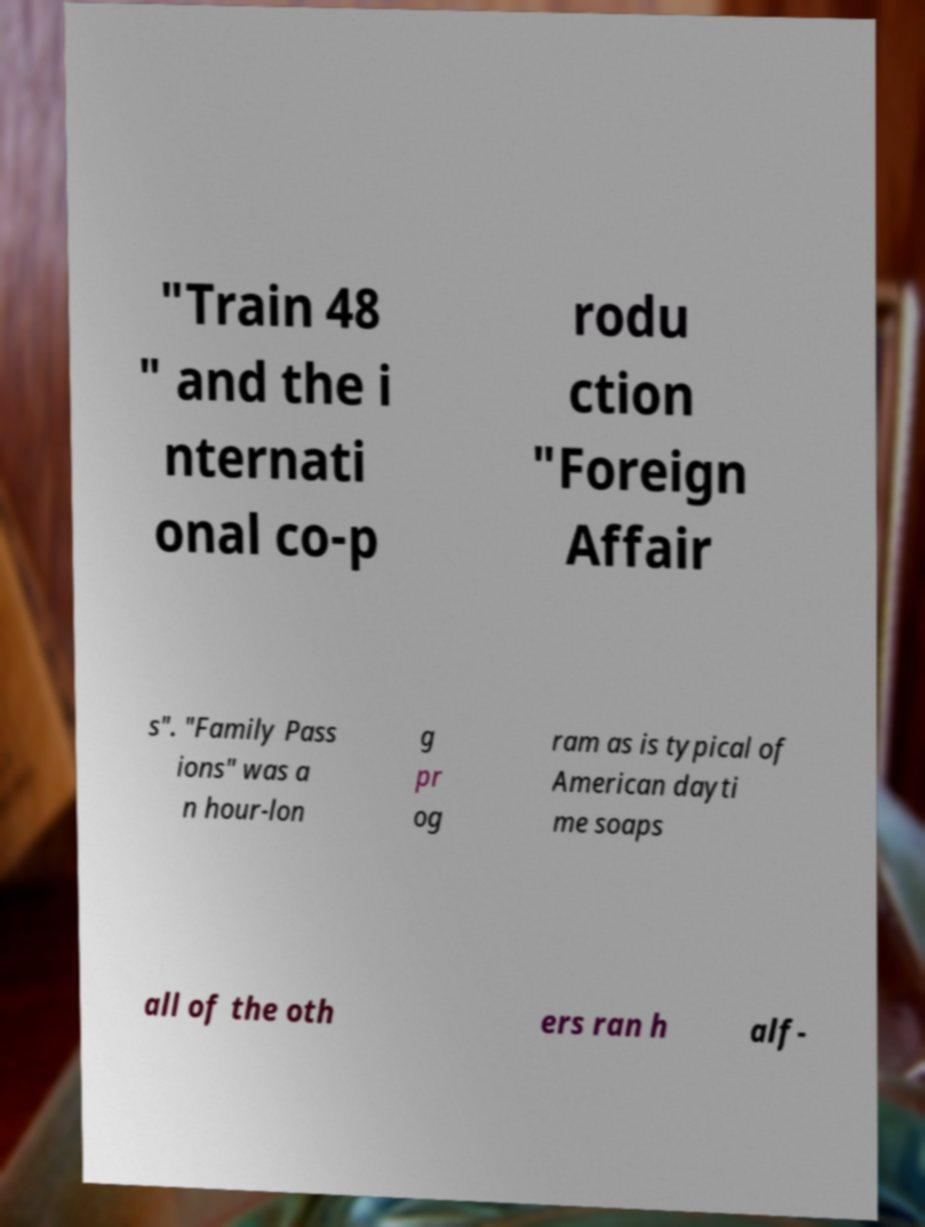Could you extract and type out the text from this image? "Train 48 " and the i nternati onal co-p rodu ction "Foreign Affair s". "Family Pass ions" was a n hour-lon g pr og ram as is typical of American dayti me soaps all of the oth ers ran h alf- 